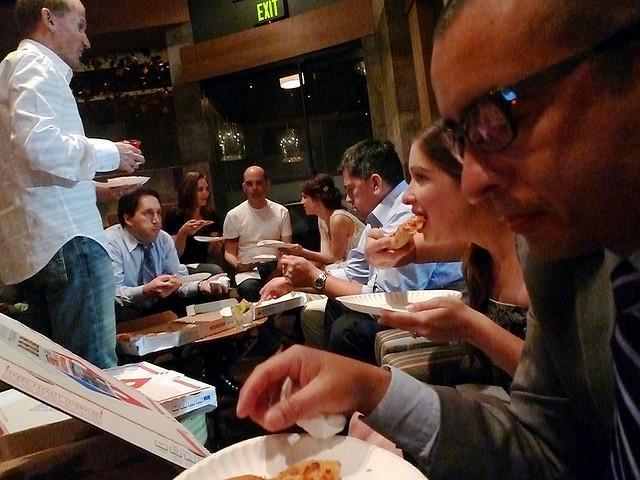How many women are in this photo?
Give a very brief answer. 3. How many people are there?
Give a very brief answer. 8. 